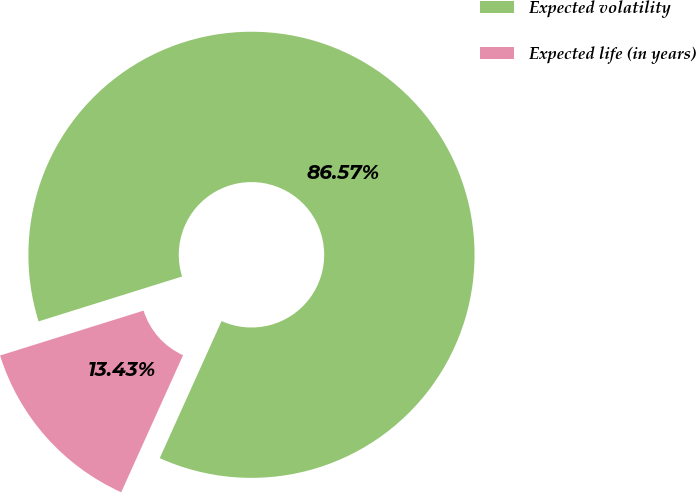Convert chart to OTSL. <chart><loc_0><loc_0><loc_500><loc_500><pie_chart><fcel>Expected volatility<fcel>Expected life (in years)<nl><fcel>86.57%<fcel>13.43%<nl></chart> 